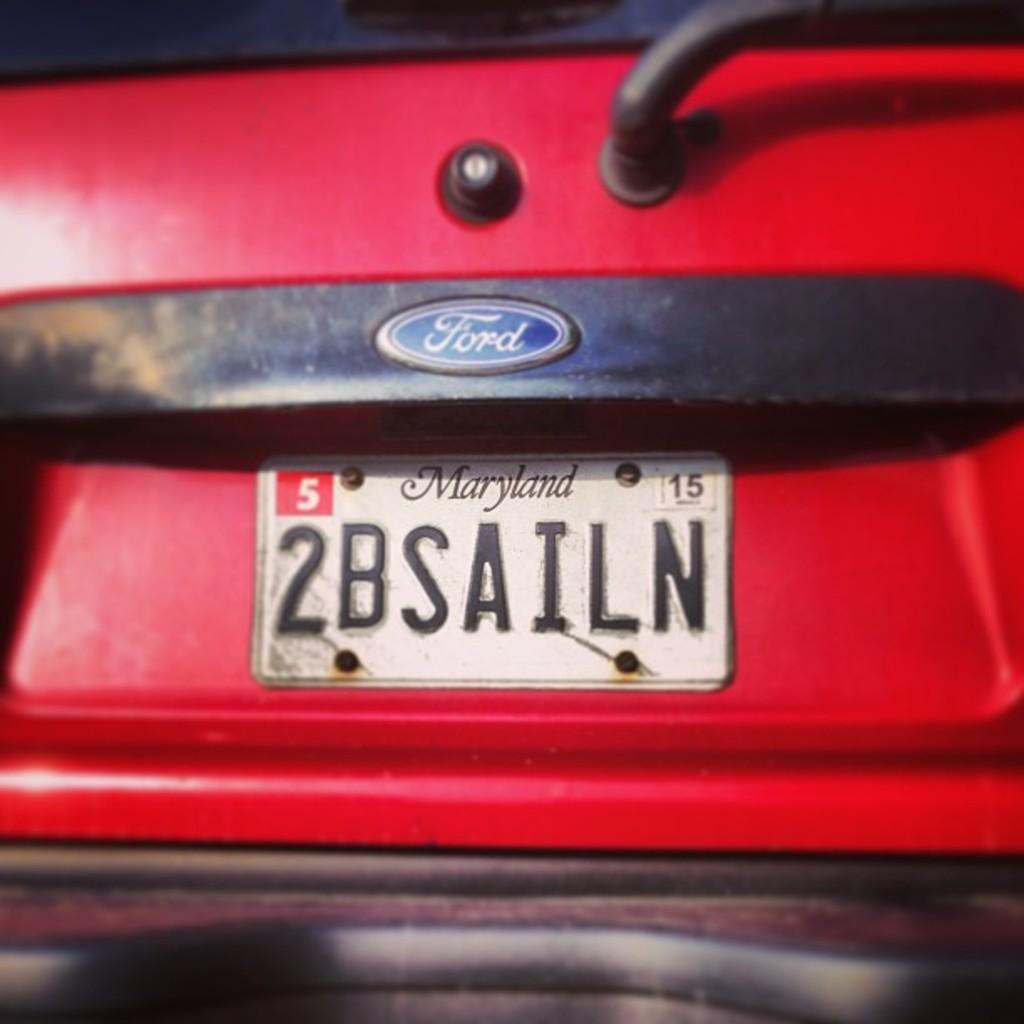Provide a one-sentence caption for the provided image. A Maryland personalized license plate on a red vehicle that reads "2BSAILN". 